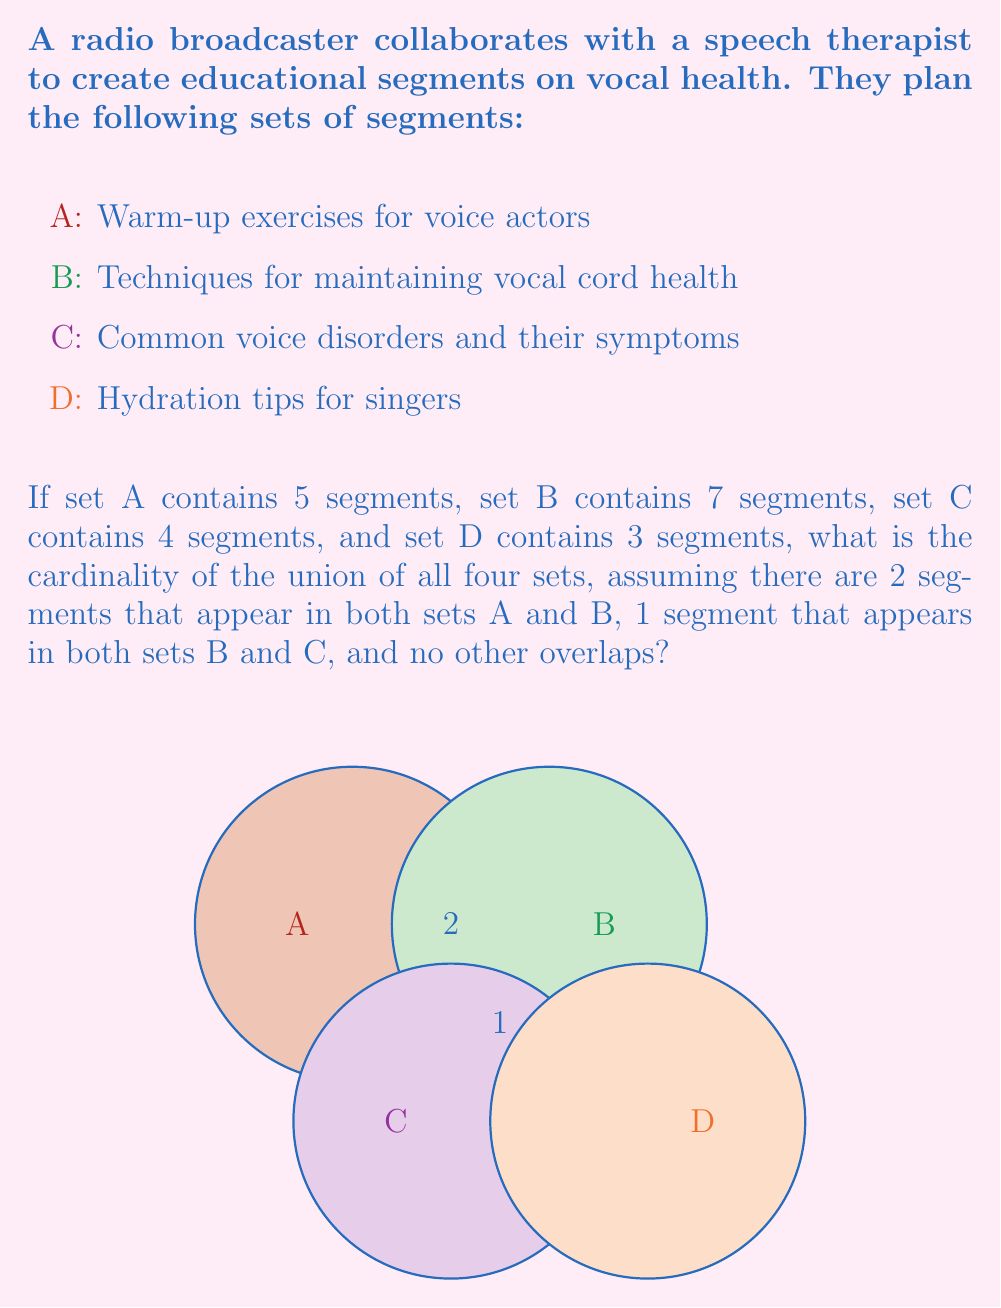Show me your answer to this math problem. Let's approach this step-by-step using the principle of inclusion-exclusion:

1) First, let's calculate the sum of the cardinalities of all sets:
   $|A| + |B| + |C| + |D| = 5 + 7 + 4 + 3 = 19$

2) However, this sum includes the overlapping elements twice, so we need to subtract them:
   - 2 segments appear in both A and B
   - 1 segment appears in both B and C

3) The formula for the cardinality of the union of these sets is:
   $|A \cup B \cup C \cup D| = |A| + |B| + |C| + |D| - |A \cap B| - |B \cap C|$

4) Substituting the values:
   $|A \cup B \cup C \cup D| = 5 + 7 + 4 + 3 - 2 - 1 = 16$

Therefore, the cardinality of the union of all four sets is 16.
Answer: 16 